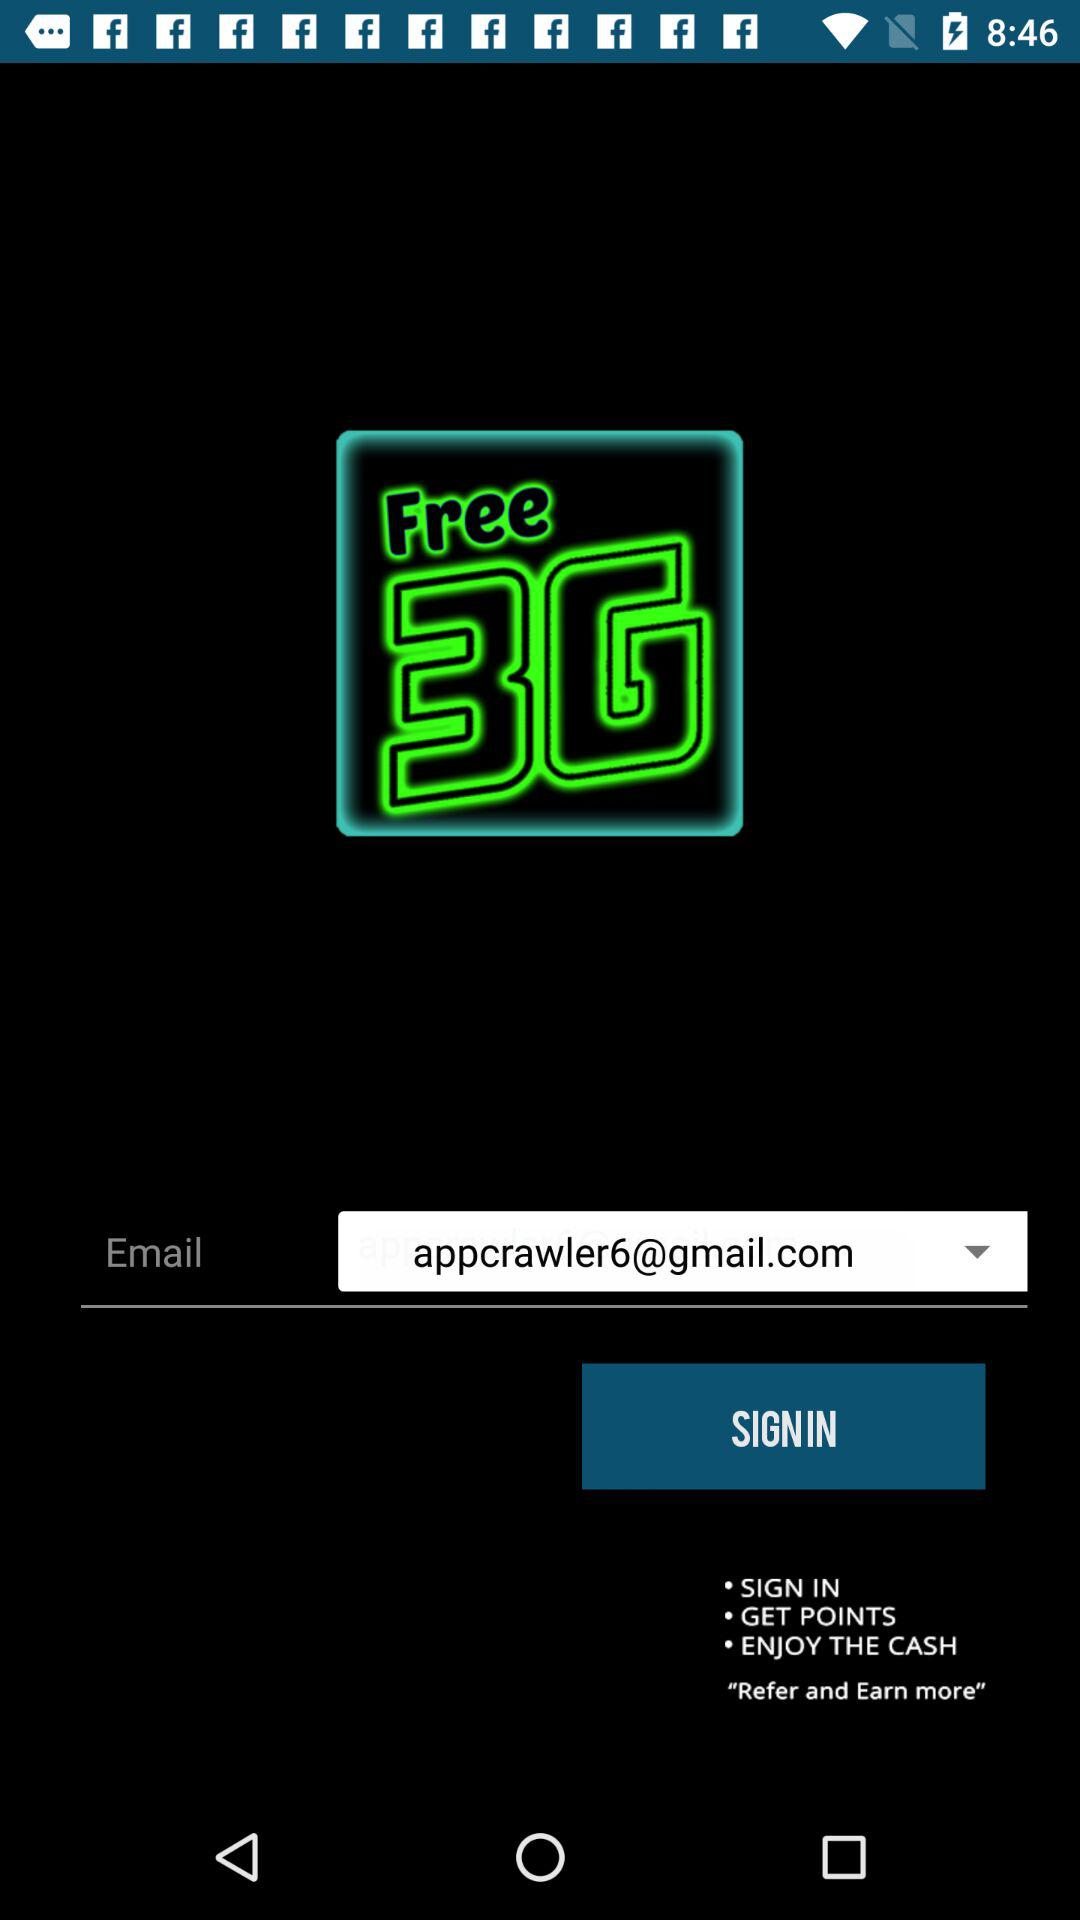What is the name of the application? The name of the application is "Free 3G Mobile data recharge". 